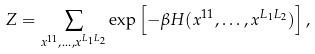<formula> <loc_0><loc_0><loc_500><loc_500>Z = \sum _ { x ^ { 1 1 } , \dots , x ^ { L _ { 1 } L _ { 2 } } } \exp \left [ - \beta H ( x ^ { 1 1 } , \dots , x ^ { L _ { 1 } L _ { 2 } } ) \right ] ,</formula> 